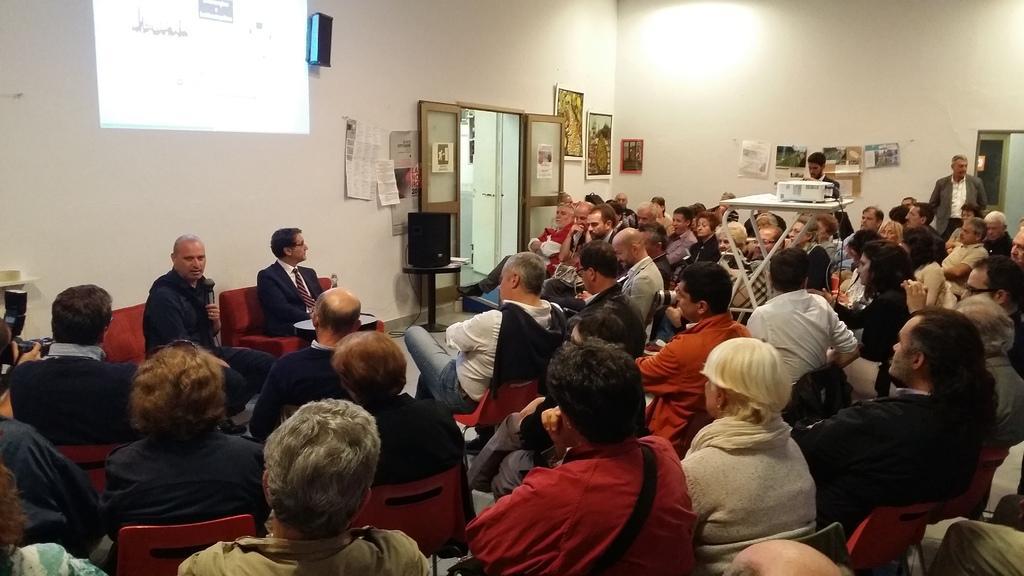Please provide a concise description of this image. In this image I can see group of people sitting. In front I can see the person and the person is wearing black color dress and holding a microphone, background I can see few frames attached to the wall and the wall is in white color and I can also see the projection screen. 